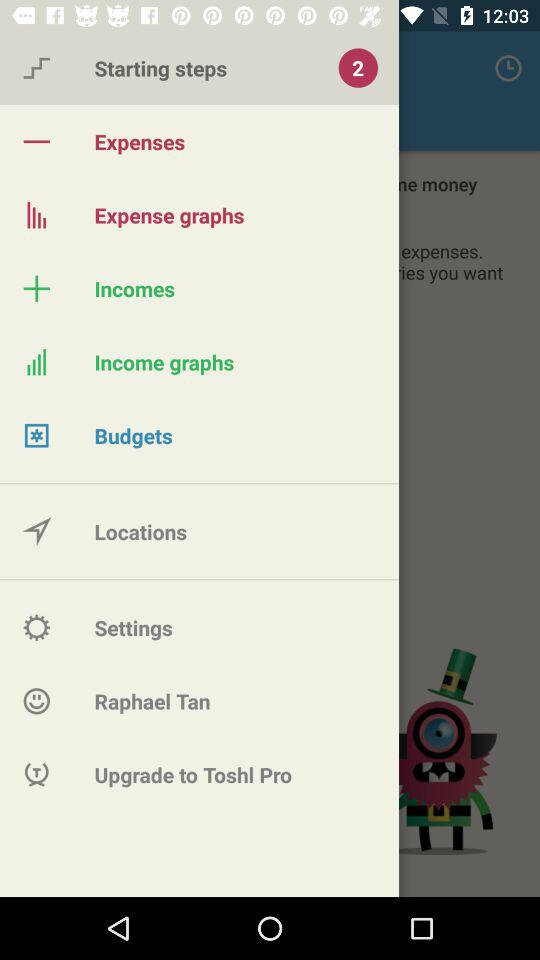How many "Starting steps" are there? There are 2 starting steps. 